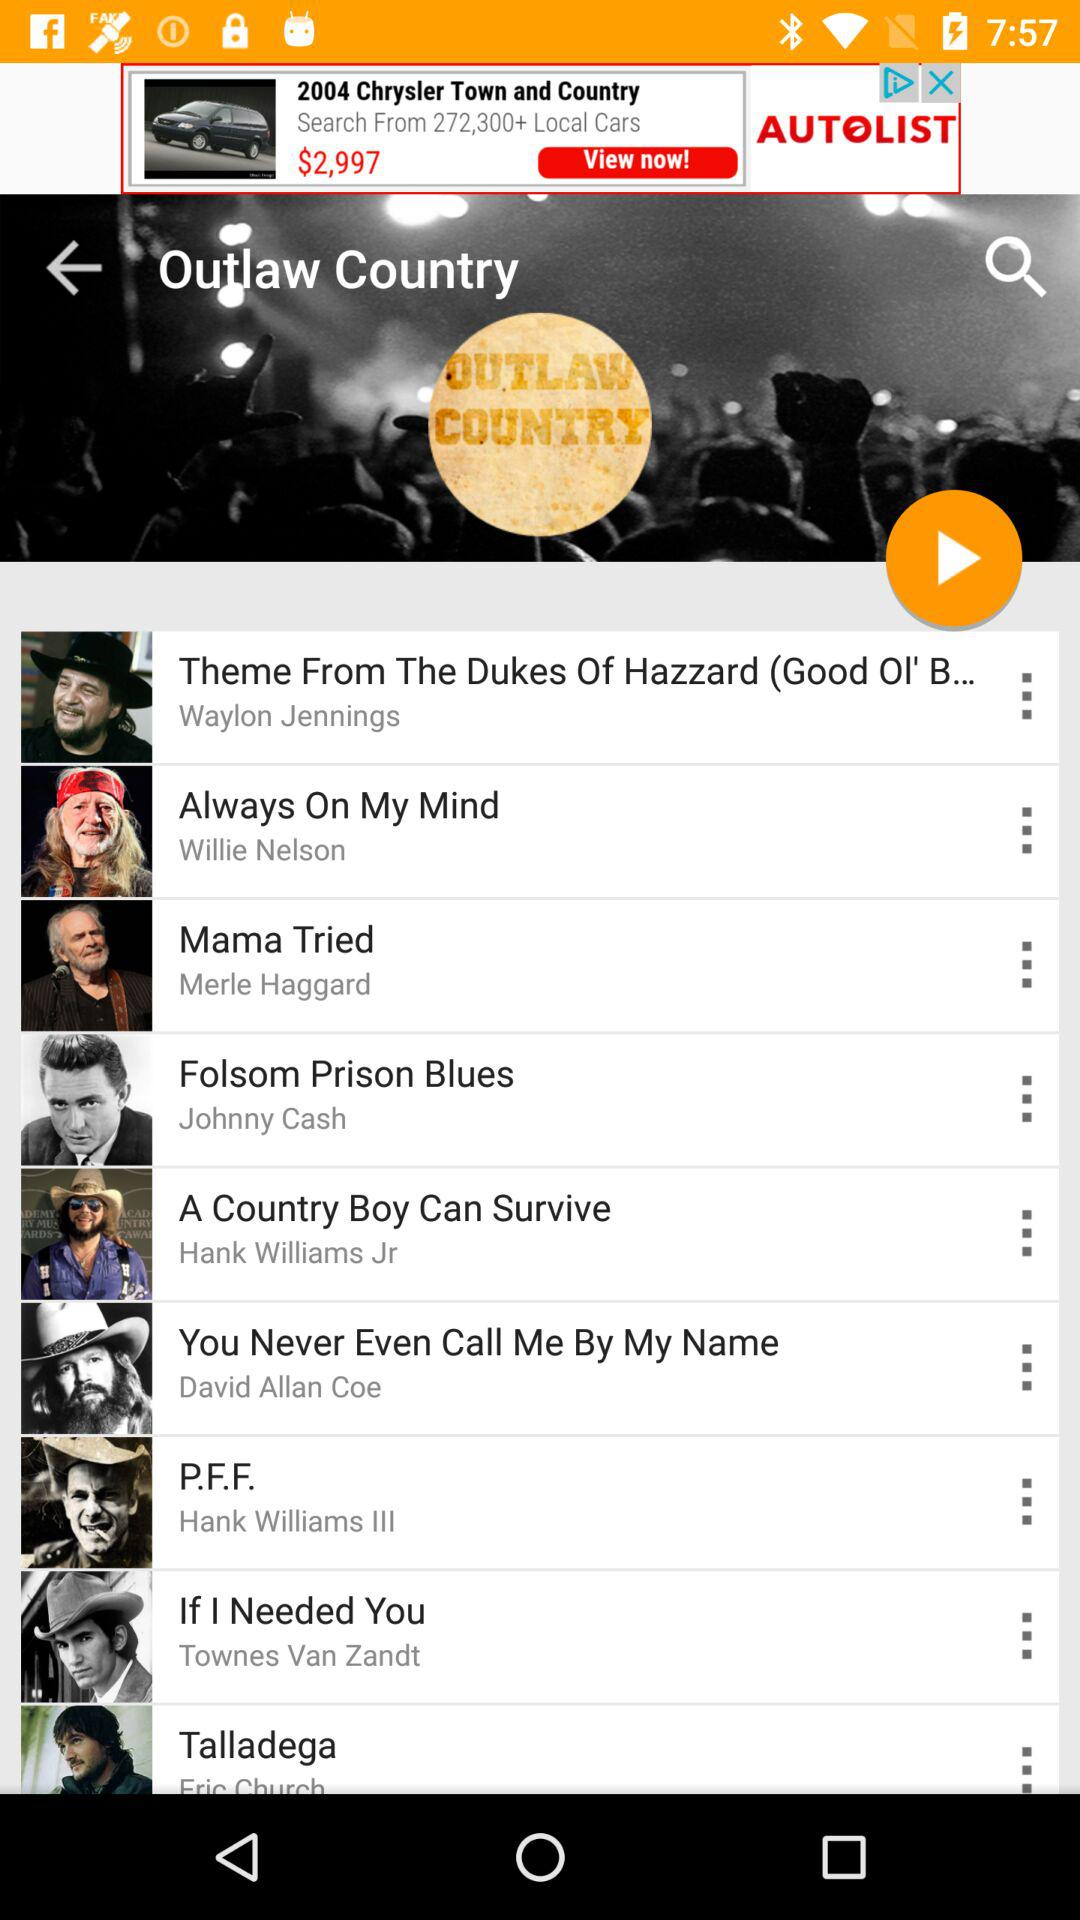Who is the singer of "Mama Tried"? The singer of "Mama Tried" is Merle Haggard. 